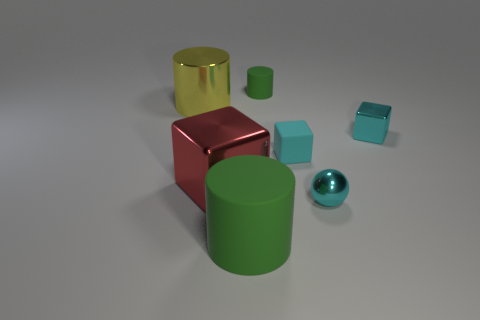Subtract all cyan cylinders. Subtract all yellow cubes. How many cylinders are left? 3 Add 1 green rubber cylinders. How many objects exist? 8 Subtract all balls. How many objects are left? 6 Add 6 tiny blocks. How many tiny blocks are left? 8 Add 7 small rubber cylinders. How many small rubber cylinders exist? 8 Subtract 0 purple cylinders. How many objects are left? 7 Subtract all small green matte things. Subtract all metal cylinders. How many objects are left? 5 